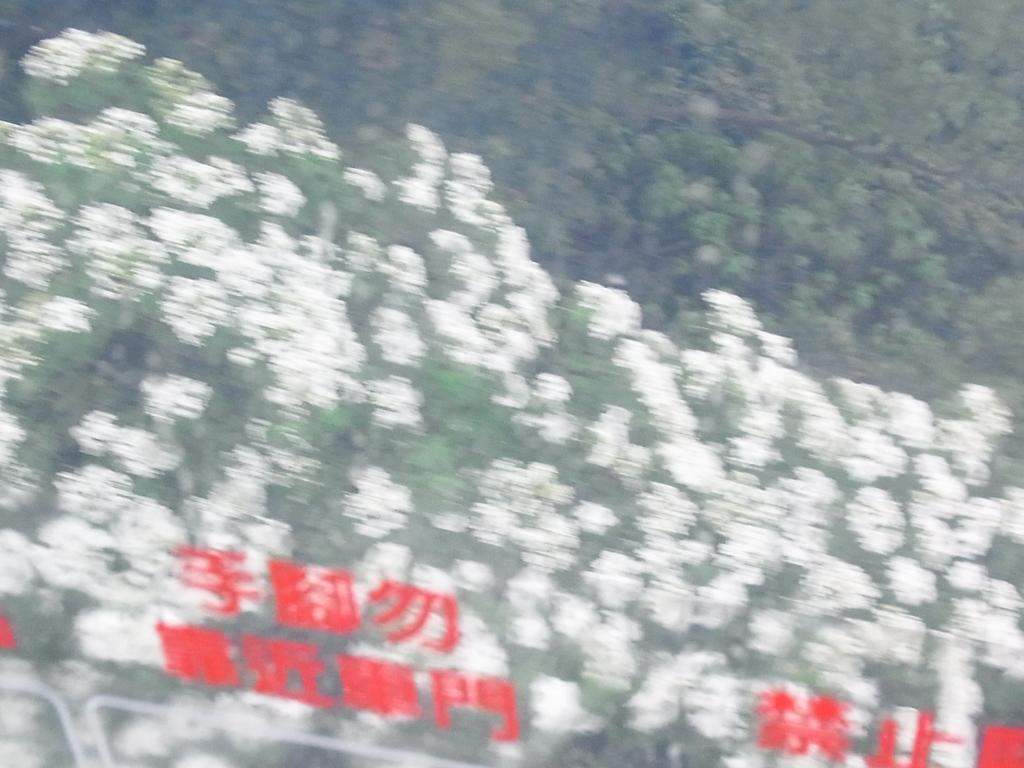What type of plants can be seen in the image? There are flowers and trees in the image. Can you describe the natural setting visible in the image? The natural setting includes flowers and trees. What else is visible in the image besides the plants? There is some text visible on the picture. What type of lettuce can be seen growing in the image? There is no lettuce present in the image; it features flowers and trees. How does the balance of the room affect the plants in the image? There is no room present in the image, so it is not possible to determine how the balance of the room might affect the plants. 